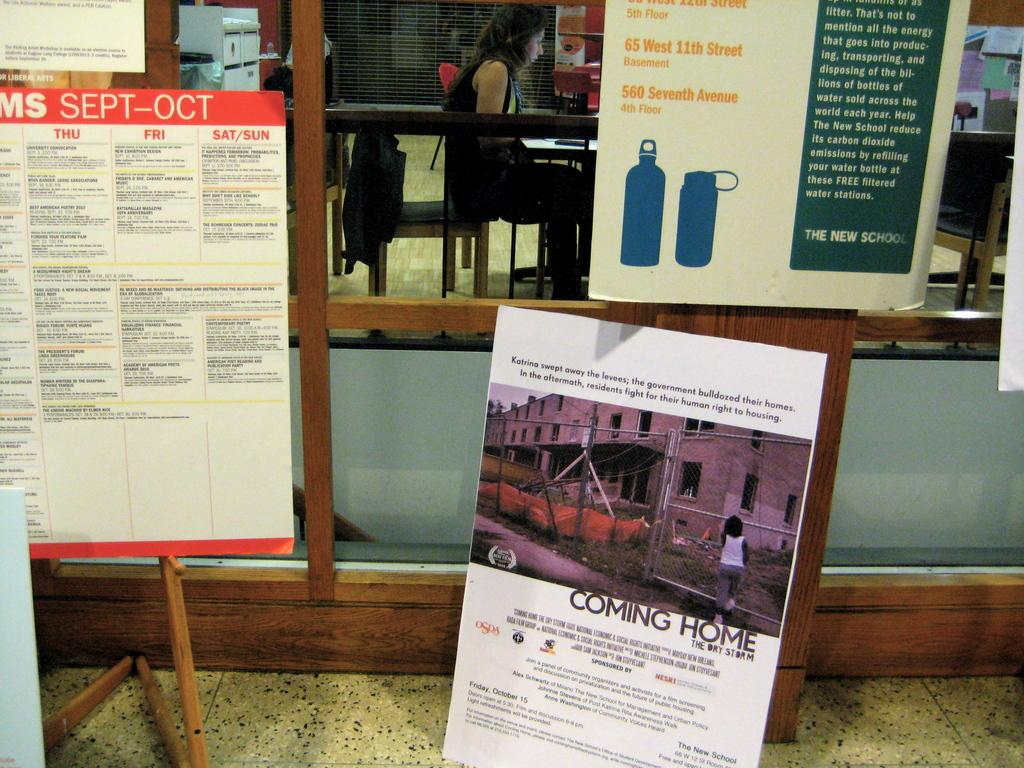<image>
Summarize the visual content of the image. Several posters, including one titled "COMING HOME" are on display. 